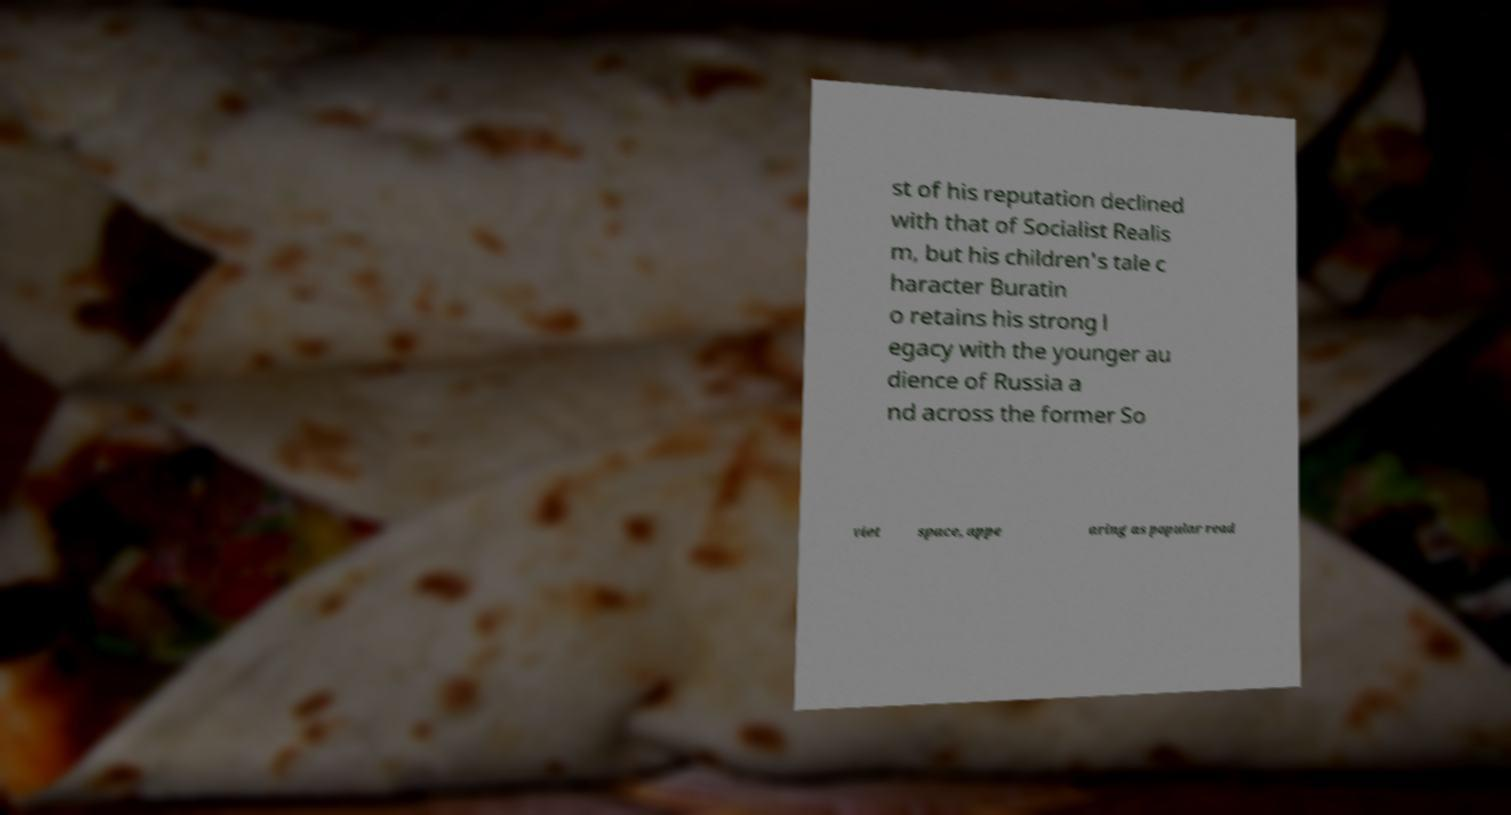Please read and relay the text visible in this image. What does it say? st of his reputation declined with that of Socialist Realis m, but his children's tale c haracter Buratin o retains his strong l egacy with the younger au dience of Russia a nd across the former So viet space, appe aring as popular read 